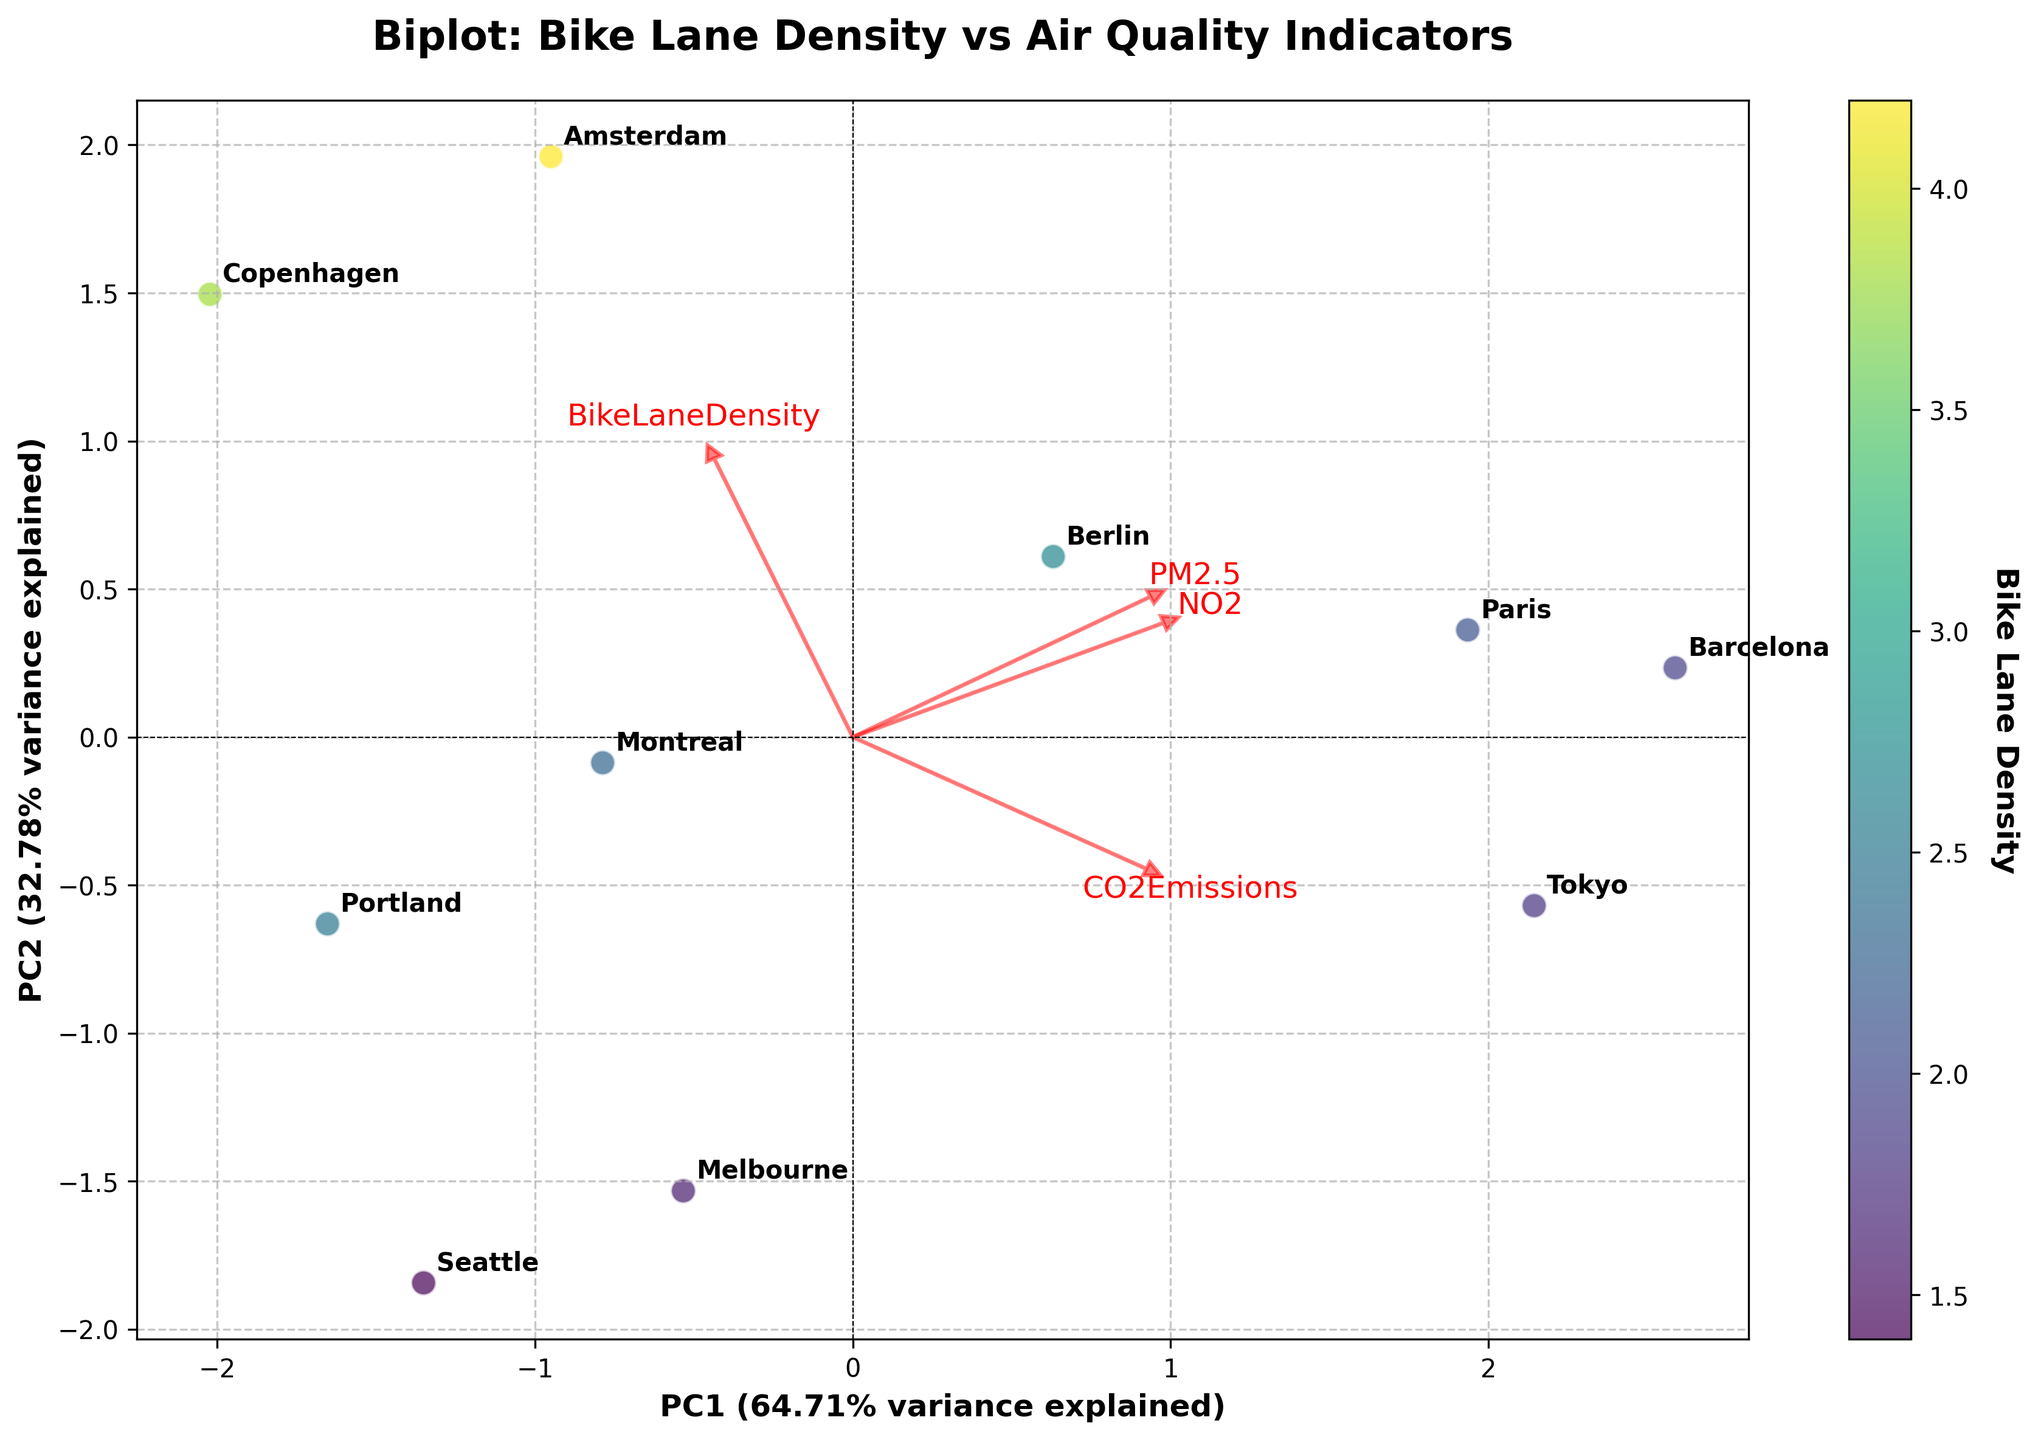How many cities are shown in the biplot? Count the number of data points on the plot and their associated labels.
Answer: 10 Which city has the highest bike lane density? Check the color gradient; cities with the highest bike lane density will have the deepest color (based on the color bar). Look for the label closest to the deepest color.
Answer: Amsterdam Which city has the lowest PM2.5 level? Find the position of the loading vector labeled "PM2.5" and see which city's data point is closest to the opposite end of this vector. The city farthest from this vector's direction has the lowest PM2.5 level.
Answer: Seattle How are bike lane density and NO2 correlated according to the biplot? Analyze the directions of the arrows (loading vectors) for Bike Lane Density and NO2. If they point in roughly the same direction, they are positively correlated; if they point in opposite directions, they are negatively correlated.
Answer: Negatively correlated What percentage of the total variance is explained by the first principal component (PC1)? Read the variance explained by PC1 from the x-axis label, which indicates the percentage of variance explained by PC1.
Answer: 46.52% Which city shows a significant deviation in CO2 emissions compared to the other cities? Look along the direction of the "CO2Emissions" arrow. Find the city that is furthest away from the origin in this direction.
Answer: Tokyo Which direction is Paris located in relative to the origin? Look at the position of Paris in relation to the origin (0,0) of the biplot.
Answer: Upper right Is there a city with similar scores on both principal components? If yes, name the city. Identify any data point that lies at an equal distance from the origin along both PC1 and PC2.
Answer: No_city_is_at_exact_same_position_on_both_axes What can you infer about Berlin's air quality indicators from its location in the biplot? Evaluate Berlin's position relative to the loading vectors for PM2.5, NO2, and CO2Emissions. Berlin lies closer to the origin, suggesting moderate values for these indicators.
Answer: Moderate levels 